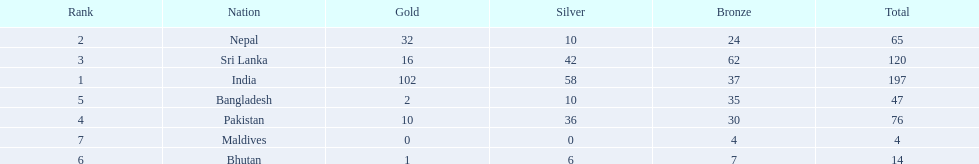What are all the countries listed in the table? India, Nepal, Sri Lanka, Pakistan, Bangladesh, Bhutan, Maldives. Which of these is not india? Nepal, Sri Lanka, Pakistan, Bangladesh, Bhutan, Maldives. Of these, which is first? Nepal. 